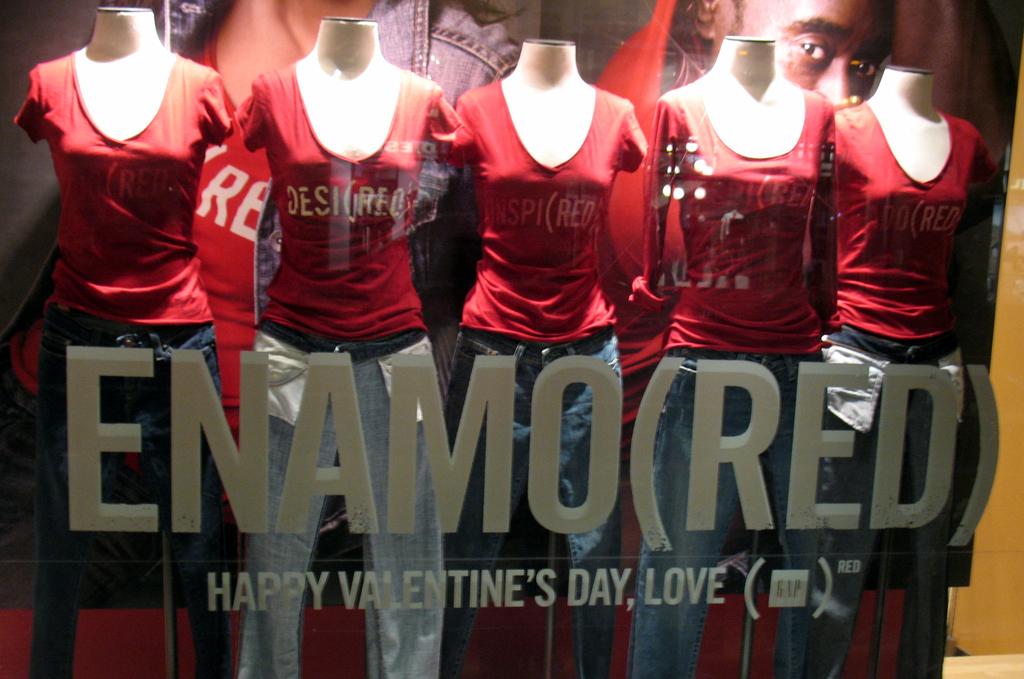What holiday is the campaign celebrating?
Make the answer very short. Valentine's day. What is the name of the store?
Provide a short and direct response. Enamored. 